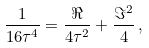<formula> <loc_0><loc_0><loc_500><loc_500>\frac { 1 } { 1 6 \tau ^ { 4 } } = \frac { \Re } { 4 \tau ^ { 2 } } + \frac { \Im ^ { 2 } } { 4 } \, ,</formula> 